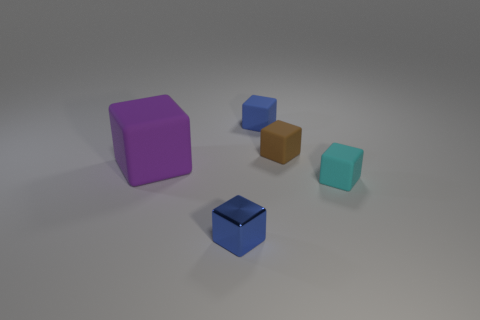Subtract all brown cubes. How many cubes are left? 4 Subtract all large rubber blocks. How many blocks are left? 4 Subtract 2 blocks. How many blocks are left? 3 Add 1 purple rubber things. How many objects exist? 6 Subtract all green cubes. Subtract all gray cylinders. How many cubes are left? 5 Add 3 large blue metallic objects. How many large blue metallic objects exist? 3 Subtract 0 green cubes. How many objects are left? 5 Subtract all cyan shiny cylinders. Subtract all blue metal blocks. How many objects are left? 4 Add 5 small blue metallic blocks. How many small blue metallic blocks are left? 6 